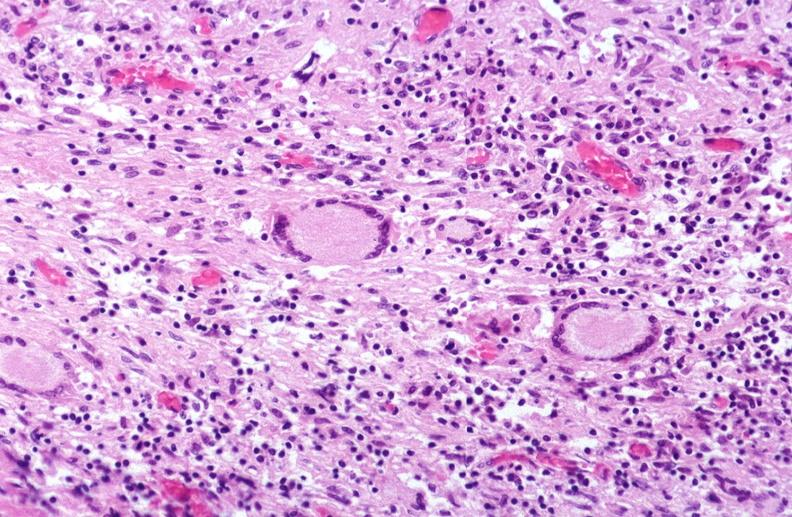does this image show lung, mycobacterium tuberculosis, granulomas and giant cells?
Answer the question using a single word or phrase. Yes 